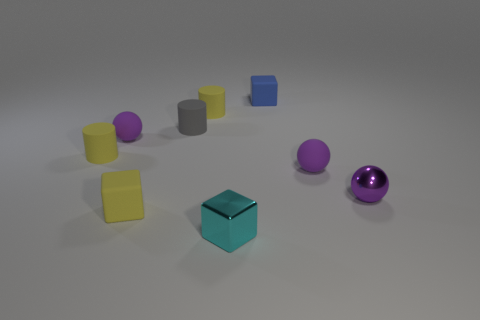How many purple balls must be subtracted to get 1 purple balls? 2 Subtract all brown spheres. How many yellow cylinders are left? 2 Subtract all purple rubber spheres. How many spheres are left? 1 Add 1 tiny blue things. How many objects exist? 10 Subtract all balls. How many objects are left? 6 Subtract 1 cylinders. How many cylinders are left? 2 Subtract all green cylinders. Subtract all green balls. How many cylinders are left? 3 Add 2 cyan cylinders. How many cyan cylinders exist? 2 Subtract 1 yellow cubes. How many objects are left? 8 Subtract all tiny yellow cylinders. Subtract all small cyan blocks. How many objects are left? 6 